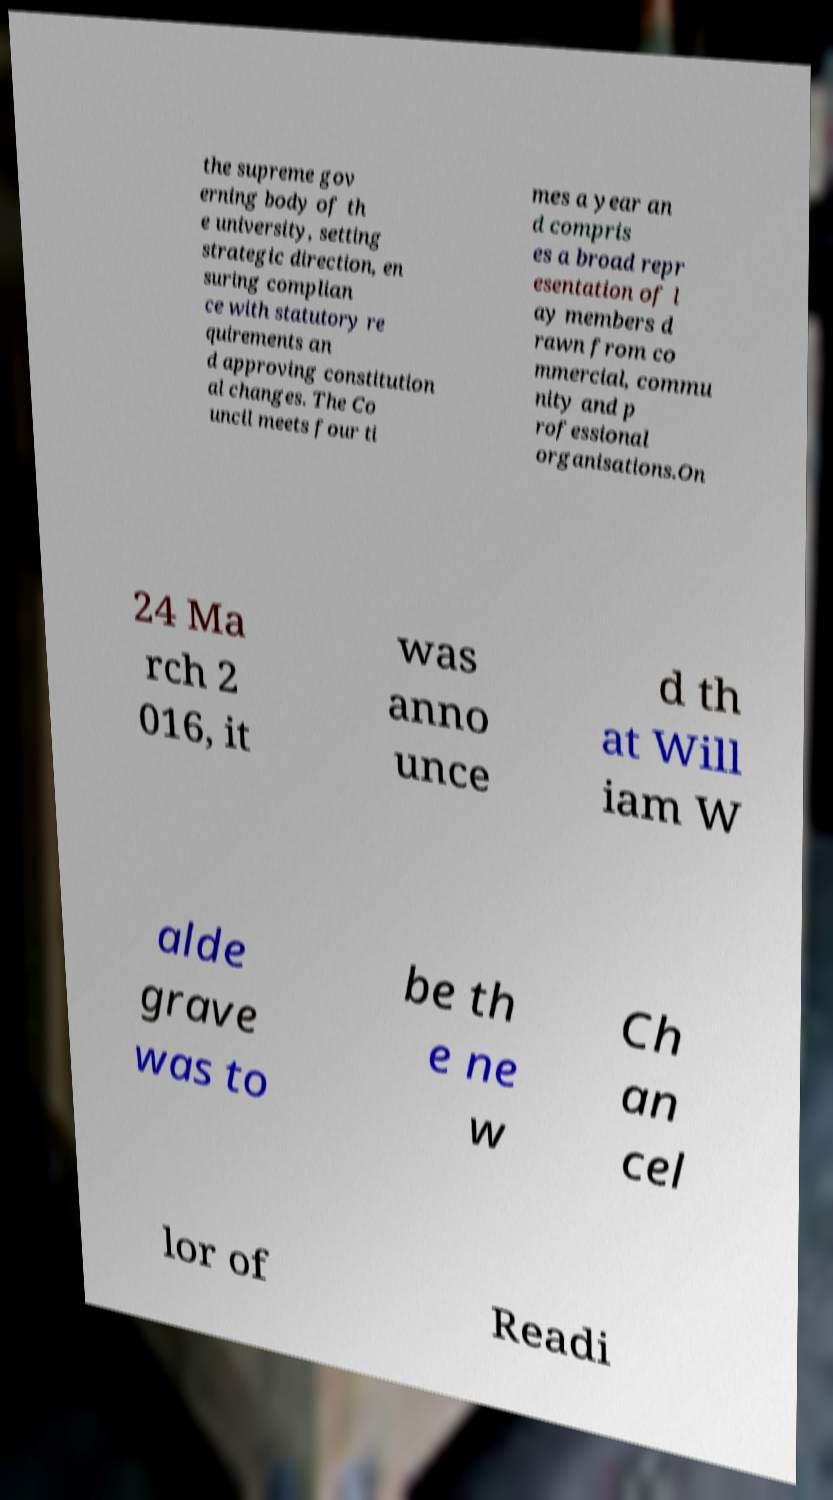Can you accurately transcribe the text from the provided image for me? the supreme gov erning body of th e university, setting strategic direction, en suring complian ce with statutory re quirements an d approving constitution al changes. The Co uncil meets four ti mes a year an d compris es a broad repr esentation of l ay members d rawn from co mmercial, commu nity and p rofessional organisations.On 24 Ma rch 2 016, it was anno unce d th at Will iam W alde grave was to be th e ne w Ch an cel lor of Readi 